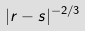<formula> <loc_0><loc_0><loc_500><loc_500>| r - s | ^ { - 2 / 3 }</formula> 